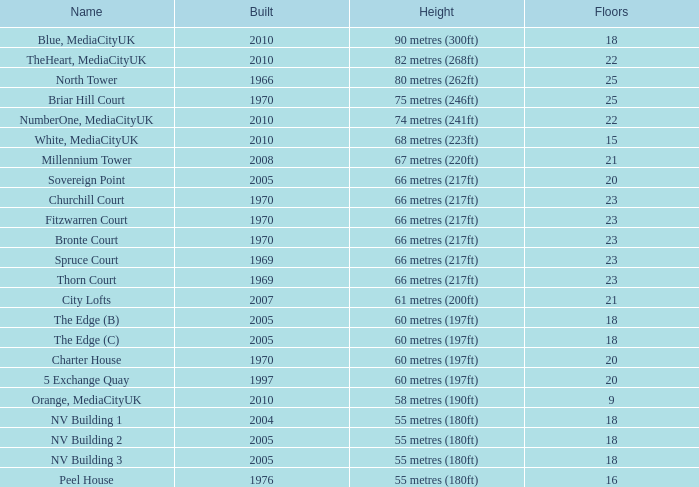What is the verticality, when standing is lesser than 20, when layers is in excess of 9, when creation is 2005, and when appellation is the edge (c)? 60 metres (197ft). 